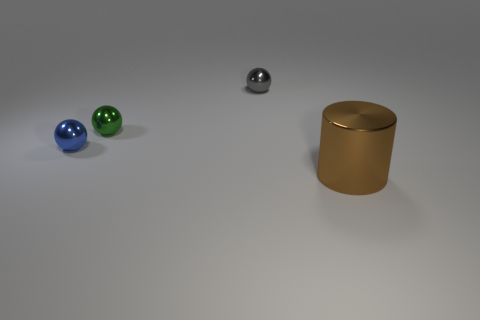Add 1 gray shiny cylinders. How many objects exist? 5 Subtract all cylinders. How many objects are left? 3 Add 4 small blue balls. How many small blue balls exist? 5 Subtract 0 cyan blocks. How many objects are left? 4 Subtract all brown metallic things. Subtract all tiny blue spheres. How many objects are left? 2 Add 3 big cylinders. How many big cylinders are left? 4 